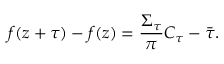Convert formula to latex. <formula><loc_0><loc_0><loc_500><loc_500>f ( z + \tau ) - f ( z ) = \frac { \Sigma _ { \tau } } { \pi } C _ { \tau } - \bar { \tau } .</formula> 